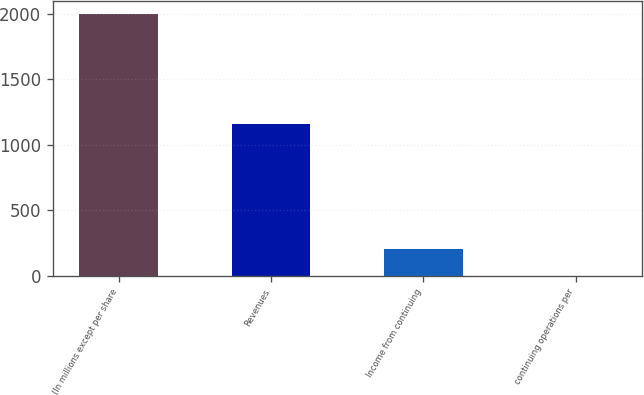Convert chart. <chart><loc_0><loc_0><loc_500><loc_500><bar_chart><fcel>(In millions except per share<fcel>Revenues<fcel>Income from continuing<fcel>continuing operations per<nl><fcel>2002<fcel>1157.9<fcel>201.38<fcel>1.31<nl></chart> 